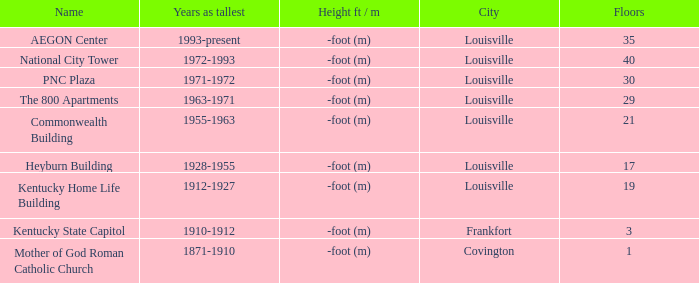In what city does the tallest building have 35 floors? Louisville. 